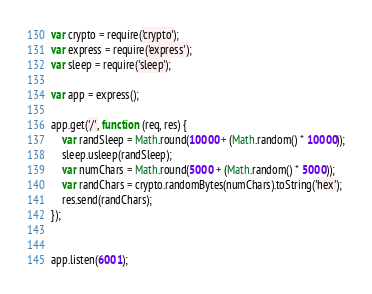<code> <loc_0><loc_0><loc_500><loc_500><_JavaScript_>var crypto = require('crypto');  
var express = require('express');  
var sleep = require('sleep');

var app = express();

app.get('/', function (req, res) { 
    var randSleep = Math.round(10000 + (Math.random() * 10000));
    sleep.usleep(randSleep);
    var numChars = Math.round(5000 + (Math.random() * 5000));
    var randChars = crypto.randomBytes(numChars).toString('hex');
    res.send(randChars);
});


app.listen(6001);
</code> 